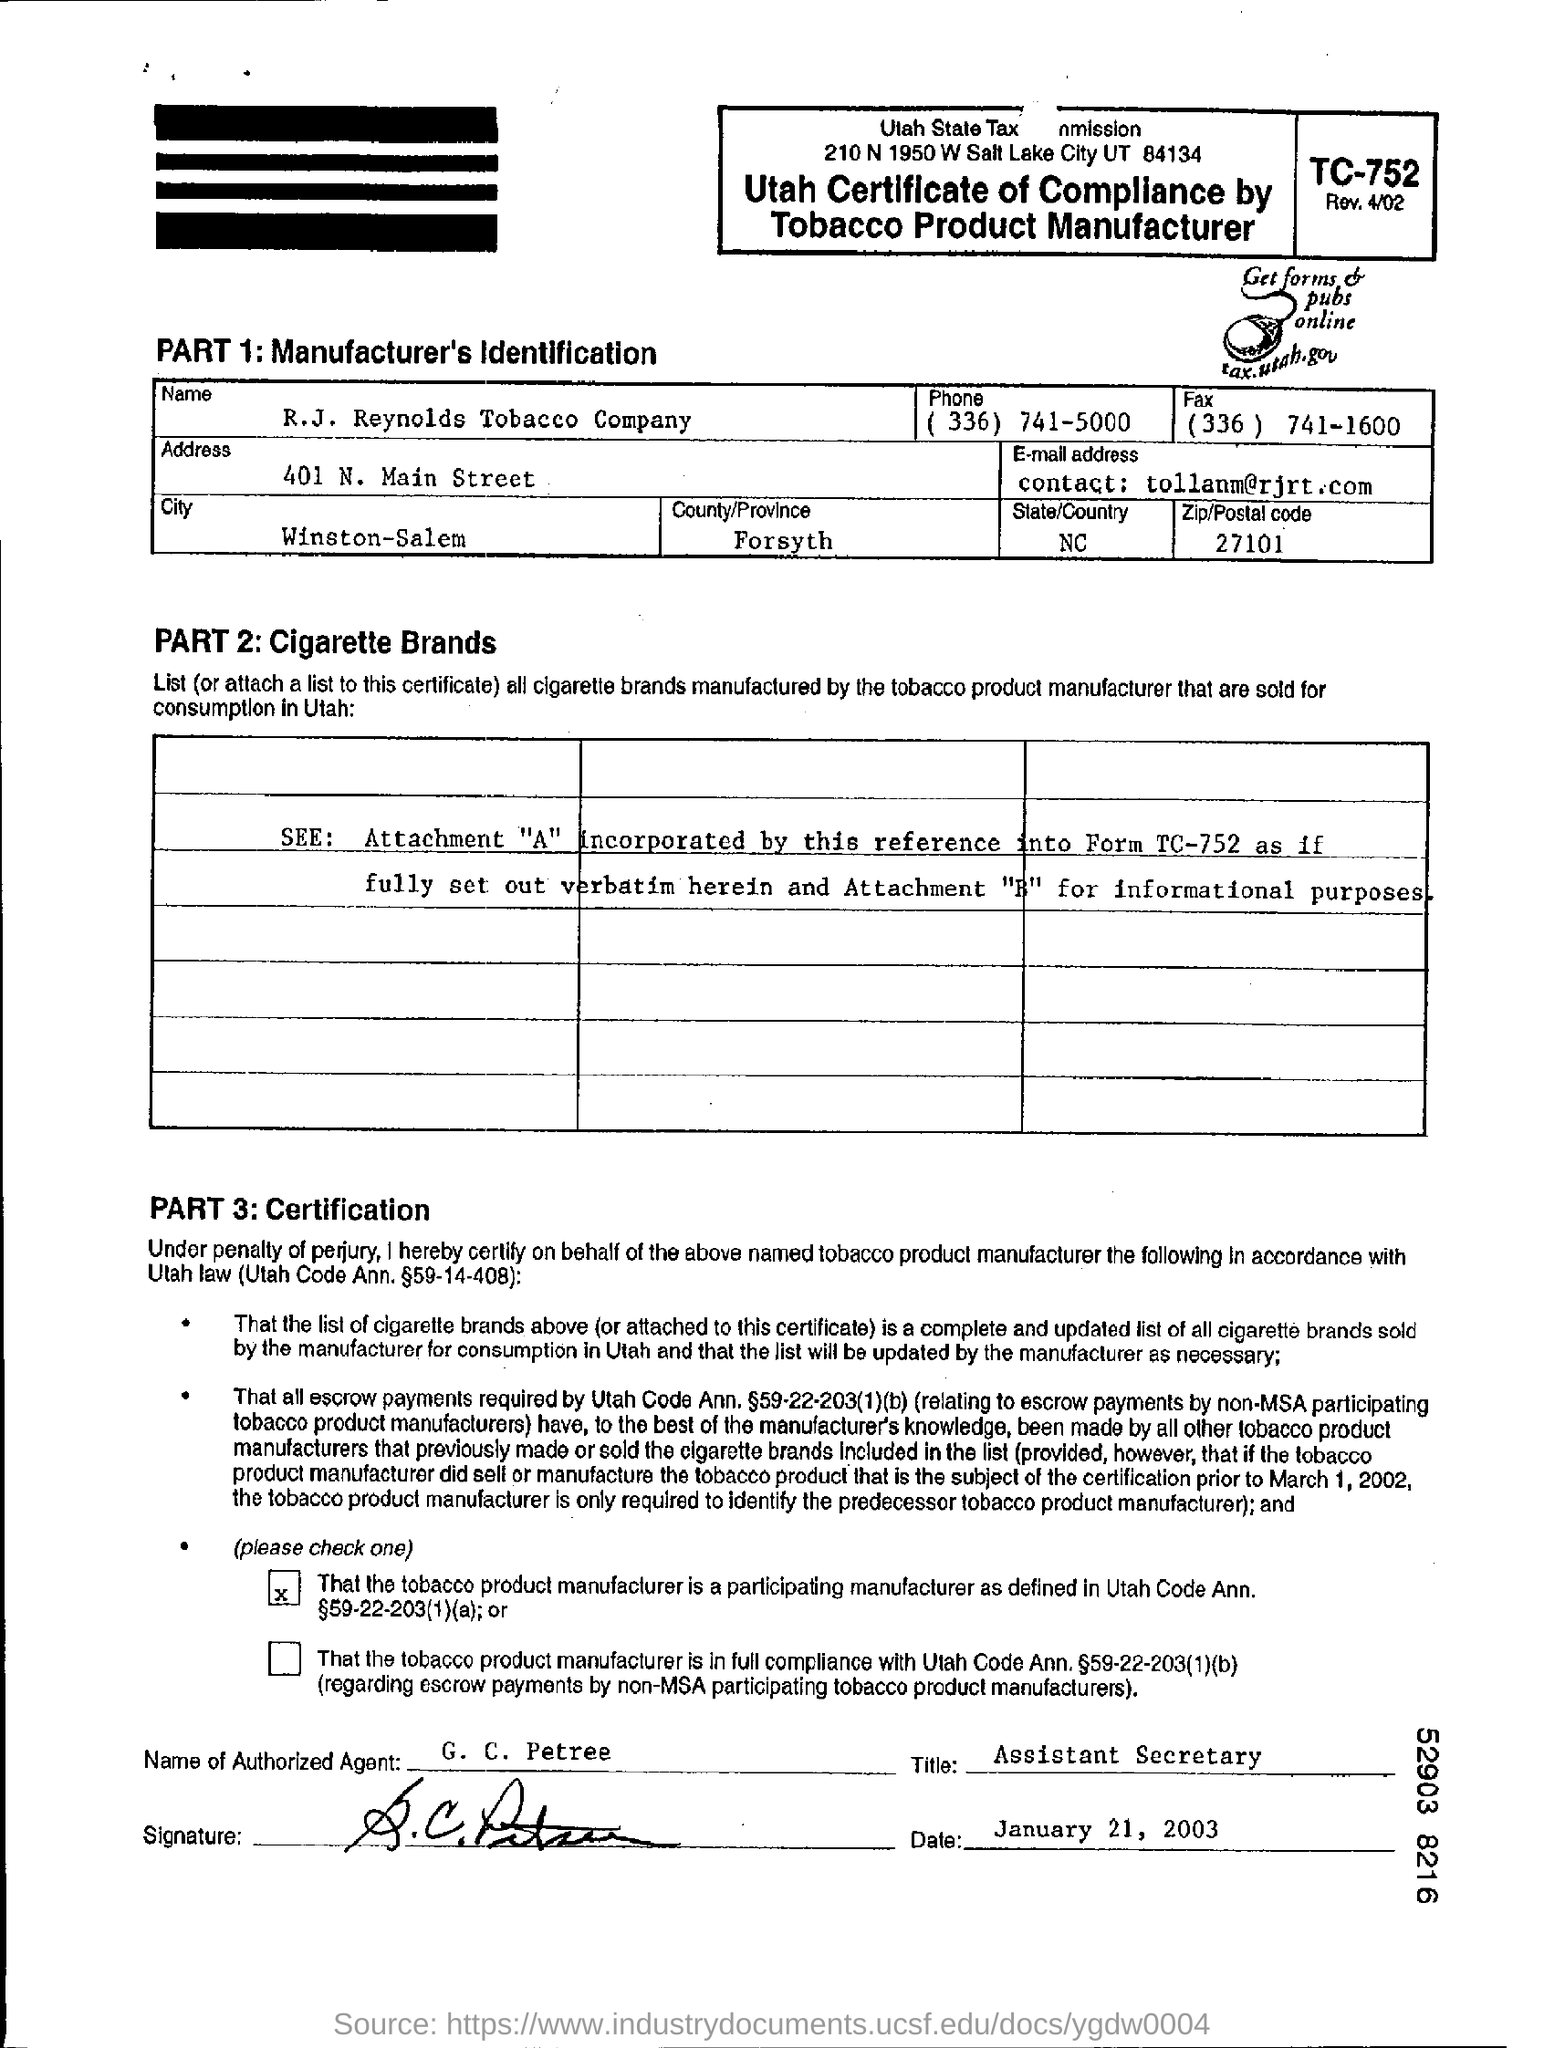What is the name of the authorized agent?
Make the answer very short. G. C. Petree. When is the certificate signed?
Keep it short and to the point. January 21, 2003. In which country or province is the company located?
Provide a short and direct response. Forsyth. In which part can you find manufacturers identification?
Provide a short and direct response. Part 1. In which part can you find certification?
Provide a succinct answer. Part 3. In which website can you get forms & pubs online ?
Provide a succinct answer. Tax.utah.gov. 